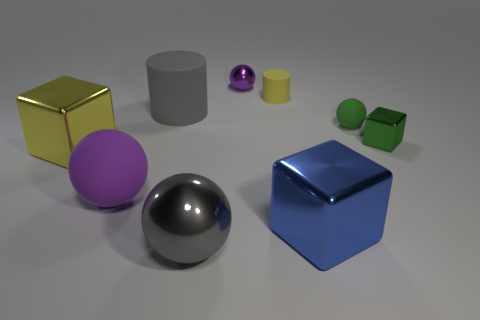What is the material of the sphere that is the same color as the small cube?
Your response must be concise. Rubber. What is the material of the big gray cylinder?
Keep it short and to the point. Rubber. Are any small blue matte blocks visible?
Your response must be concise. No. There is a large rubber thing that is to the right of the big purple ball; what is its color?
Your answer should be compact. Gray. What number of rubber balls are right of the large purple thing in front of the tiny ball that is behind the green sphere?
Provide a short and direct response. 1. What is the material of the small thing that is in front of the big gray matte cylinder and left of the green metallic block?
Your answer should be very brief. Rubber. Is the material of the large blue block the same as the big sphere on the left side of the gray metallic ball?
Offer a very short reply. No. Is the number of big shiny spheres in front of the large matte ball greater than the number of small yellow cylinders left of the gray matte thing?
Provide a succinct answer. Yes. What shape is the big yellow thing?
Ensure brevity in your answer.  Cube. Are the gray object in front of the tiny green sphere and the purple sphere that is in front of the yellow cube made of the same material?
Offer a very short reply. No. 